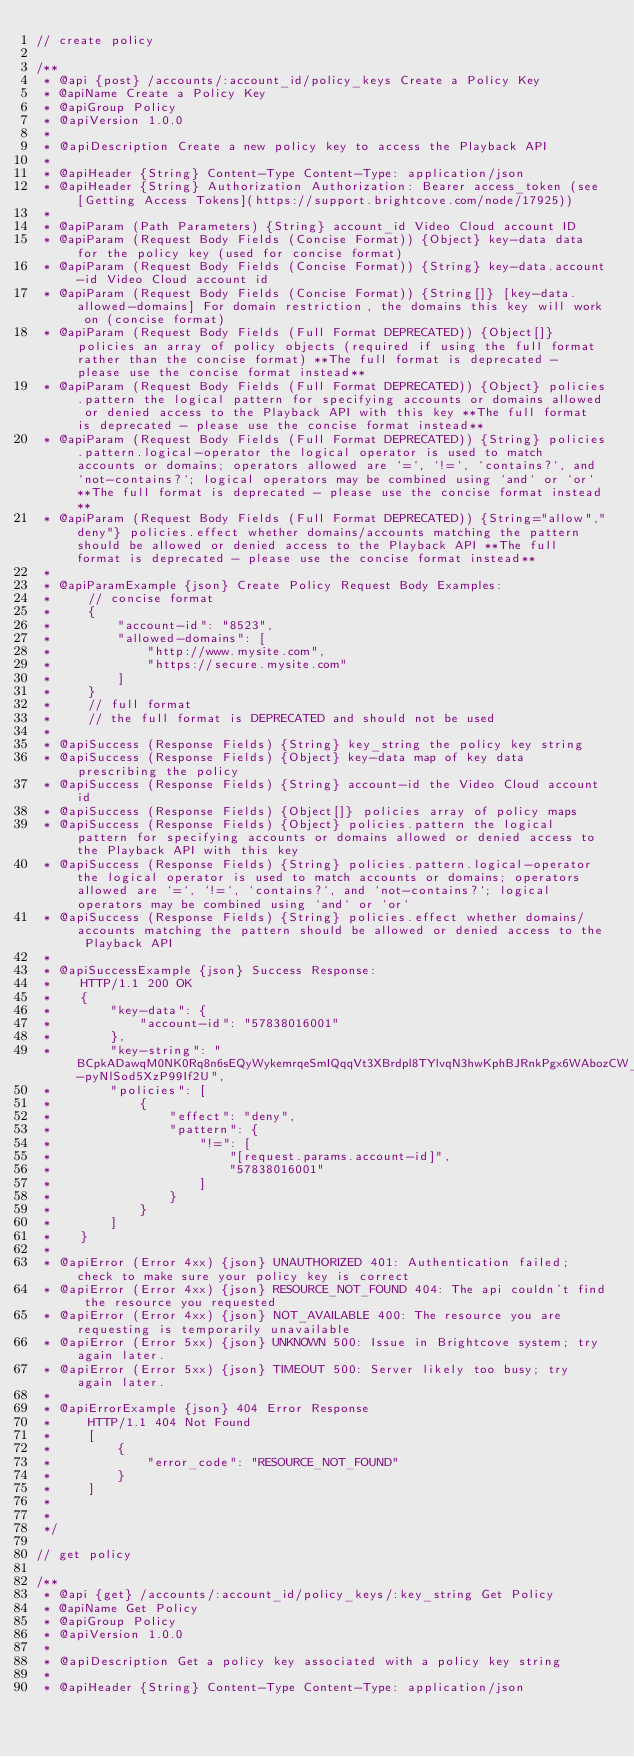<code> <loc_0><loc_0><loc_500><loc_500><_JavaScript_>// create policy

/**
 * @api {post} /accounts/:account_id/policy_keys Create a Policy Key
 * @apiName Create a Policy Key
 * @apiGroup Policy
 * @apiVersion 1.0.0
 *
 * @apiDescription Create a new policy key to access the Playback API
 *
 * @apiHeader {String} Content-Type Content-Type: application/json
 * @apiHeader {String} Authorization Authorization: Bearer access_token (see [Getting Access Tokens](https://support.brightcove.com/node/17925))
 *
 * @apiParam (Path Parameters) {String} account_id Video Cloud account ID
 * @apiParam (Request Body Fields (Concise Format)) {Object} key-data data for the policy key (used for concise format)
 * @apiParam (Request Body Fields (Concise Format)) {String} key-data.account-id Video Cloud account id
 * @apiParam (Request Body Fields (Concise Format)) {String[]} [key-data.allowed-domains] For domain restriction, the domains this key will work on (concise format)
 * @apiParam (Request Body Fields (Full Format DEPRECATED)) {Object[]} policies an array of policy objects (required if using the full format rather than the concise format) **The full format is deprecated - please use the concise format instead**
 * @apiParam (Request Body Fields (Full Format DEPRECATED)) {Object} policies.pattern the logical pattern for specifying accounts or domains allowed or denied access to the Playback API with this key **The full format is deprecated - please use the concise format instead**
 * @apiParam (Request Body Fields (Full Format DEPRECATED)) {String} policies.pattern.logical-operator the logical operator is used to match accounts or domains; operators allowed are `=`, `!=`, `contains?`, and `not-contains?`; logical operators may be combined using `and` or `or` **The full format is deprecated - please use the concise format instead**
 * @apiParam (Request Body Fields (Full Format DEPRECATED)) {String="allow","deny"} policies.effect whether domains/accounts matching the pattern should be allowed or denied access to the Playback API **The full format is deprecated - please use the concise format instead**
 *
 * @apiParamExample {json} Create Policy Request Body Examples:
 *     // concise format
 *     {
 *         "account-id": "8523",
 *         "allowed-domains": [
 *             "http://www.mysite.com",
 *             "https://secure.mysite.com"
 *         ]
 *     }
 *     // full format
 *     // the full format is DEPRECATED and should not be used
 *
 * @apiSuccess (Response Fields) {String} key_string the policy key string
 * @apiSuccess (Response Fields) {Object} key-data map of key data prescribing the policy
 * @apiSuccess (Response Fields) {String} account-id the Video Cloud account id
 * @apiSuccess (Response Fields) {Object[]} policies array of policy maps
 * @apiSuccess (Response Fields) {Object} policies.pattern the logical pattern for specifying accounts or domains allowed or denied access to the Playback API with this key
 * @apiSuccess (Response Fields) {String} policies.pattern.logical-operator the logical operator is used to match accounts or domains; operators allowed are `=`, `!=`, `contains?`, and `not-contains?`; logical operators may be combined using `and` or `or`
 * @apiSuccess (Response Fields) {String} policies.effect whether domains/accounts matching the pattern should be allowed or denied access to the Playback API
 *
 * @apiSuccessExample {json} Success Response:
 *    HTTP/1.1 200 OK
 *    {
 *        "key-data": {
 *            "account-id": "57838016001"
 *        },
 *        "key-string": "BCpkADawqM0NK0Rq8n6sEQyWykemrqeSmIQqqVt3XBrdpl8TYlvqN3hwKphBJRnkPgx6WAbozCW_VgTOBCNf1AQRh8KnmXSXfveQalRc5-pyNlSod5XzP99If2U",
 *        "policies": [
 *            {
 *                "effect": "deny",
 *                "pattern": {
 *                    "!=": [
 *                        "[request.params.account-id]",
 *                        "57838016001"
 *                    ]
 *                }
 *            }
 *        ]
 *    }
 *
 * @apiError (Error 4xx) {json} UNAUTHORIZED 401: Authentication failed; check to make sure your policy key is correct
 * @apiError (Error 4xx) {json} RESOURCE_NOT_FOUND 404: The api couldn't find the resource you requested
 * @apiError (Error 4xx) {json} NOT_AVAILABLE 400: The resource you are requesting is temporarily unavailable
 * @apiError (Error 5xx) {json} UNKNOWN 500: Issue in Brightcove system; try again later.
 * @apiError (Error 5xx) {json} TIMEOUT 500: Server likely too busy; try again later.
 *
 * @apiErrorExample {json} 404 Error Response
 *     HTTP/1.1 404 Not Found
 *     [
 *         {
 *             "error_code": "RESOURCE_NOT_FOUND"
 *         }
 *     ]
 *
 *
 */

// get policy

/**
 * @api {get} /accounts/:account_id/policy_keys/:key_string Get Policy
 * @apiName Get Policy
 * @apiGroup Policy
 * @apiVersion 1.0.0
 *
 * @apiDescription Get a policy key associated with a policy key string
 *
 * @apiHeader {String} Content-Type Content-Type: application/json</code> 